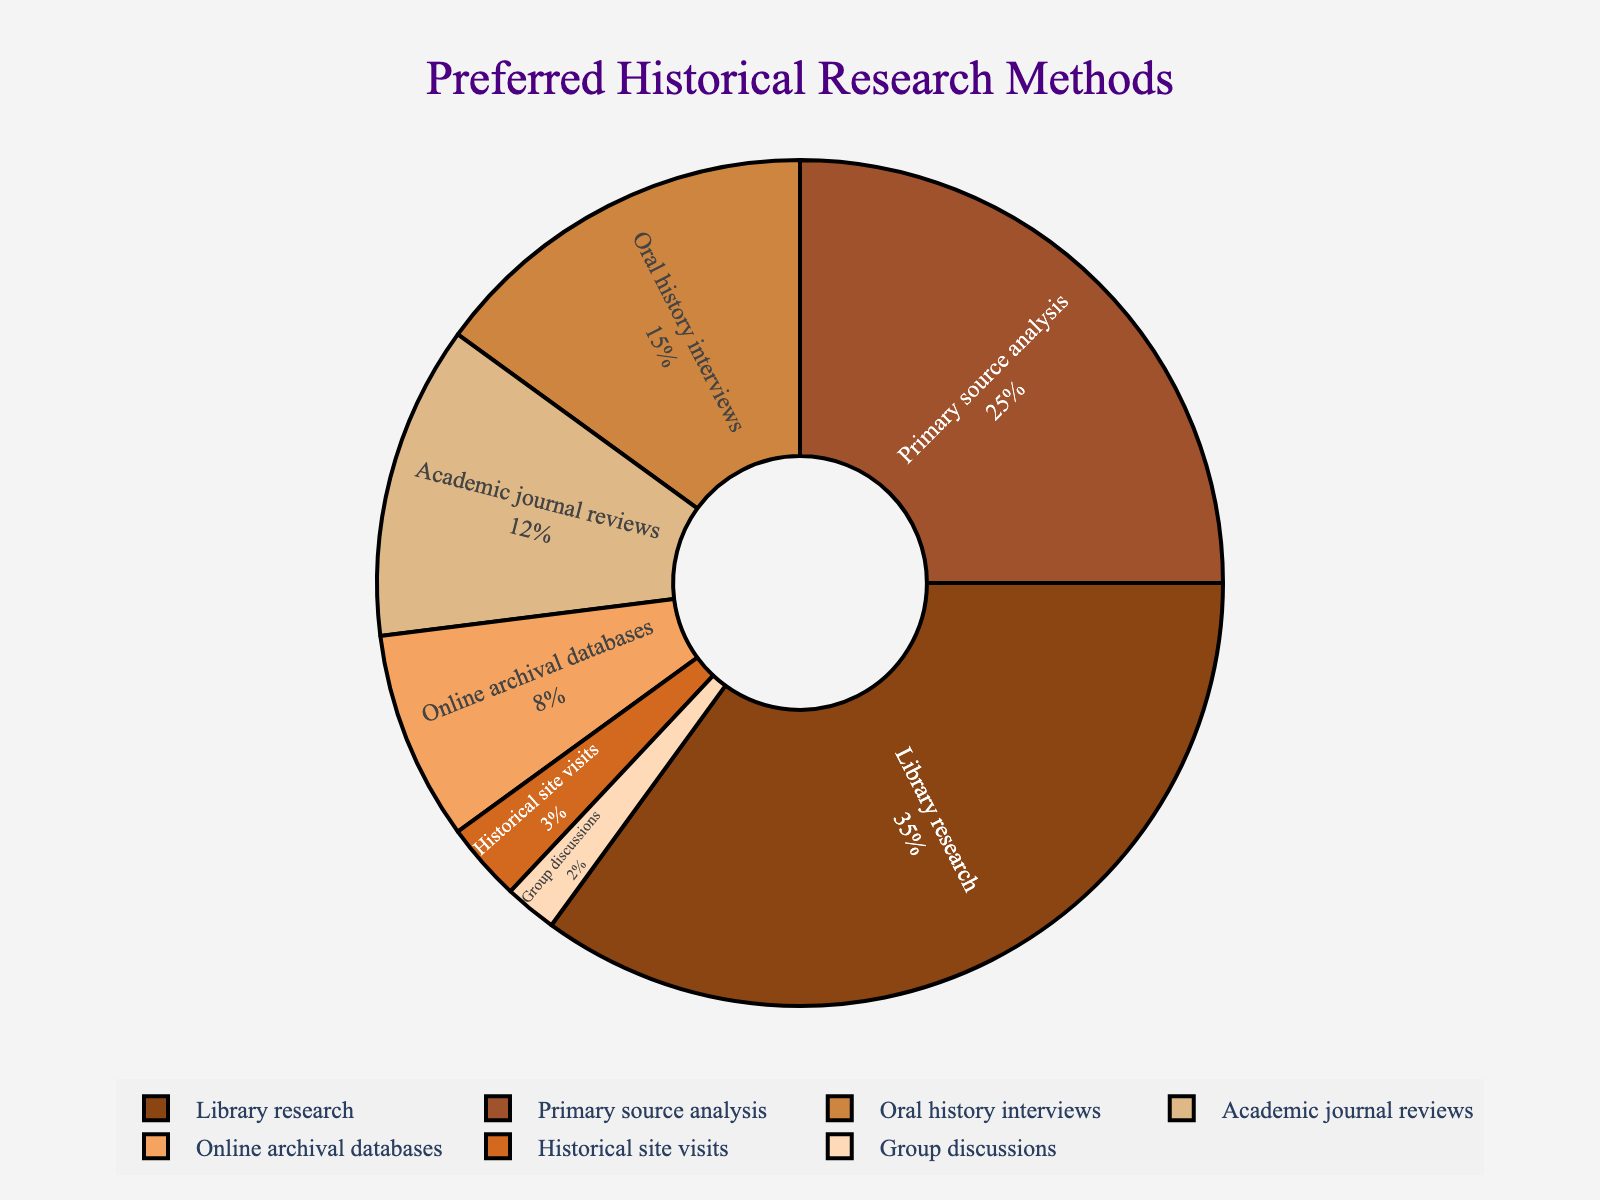Which method is the most preferred among the group members? The method with the highest percentage in the pie chart is the most preferred. The slice labeled "Library research" has the highest value at 35%.
Answer: Library research Which two methods combined make up an equal percentage to Primary source analysis? The percentage for Primary source analysis is 25%. Adding Oral history interviews (15%) and Academic journal reviews (12%) equals 27%, the closest combination to 25% that exceeds it.
Answer: Oral history interviews and Academic journal reviews How much larger is the percentage of Library research compared to Group discussions? The percentage for Library research is 35% and for Group discussions is 2%. The difference can be calculated as 35% - 2% = 33%.
Answer: 33% What is the total percentage of methods that include "analysis" or "reviews"? Adding the percentages for Primary source analysis (25%) and Academic journal reviews (12%) gives 25% + 12% = 37%.
Answer: 37% What color represents Oral history interviews in the pie chart? The slice labeled "Oral history interviews" is the fourth slice in the list of colors given, matching the color Burnt Sienna from the palette used.
Answer: Burnt Sienna Compare the use of Online archival databases to Historical site visits. Which is more frequently preferred? The percentage for Online archival databases is 8%, while Historical site visits is 3%. Since 8% > 3%, Online archival databases is more frequently preferred.
Answer: Online archival databases What is the difference in preference percentage between the second and third most preferred methods? The second most preferred method is Primary source analysis at 25%, and the third is Oral history interviews at 15%. The difference is 25% - 15% = 10%.
Answer: 10% If we consider only methods that have more than 10% preference, what is their combined percentage? The methods with more than 10% preference are Library research (35%), Primary source analysis (25%), Oral history interviews (15%), and Academic journal reviews (12%). Adding these gives 35% + 25% + 15% + 12% = 87%.
Answer: 87% Which slice appears to be the smallest one in the pie chart, and what is its percentage? The smallest slice visually appears to be "Group discussions" with the smallest value at 2%.
Answer: Group discussions at 2% Is there any method that is preferred by exactly one-fourth of the group? One-fourth of the group means 25% of the total. The method labeled "Primary source analysis" has this exact percentage.
Answer: Primary source analysis 